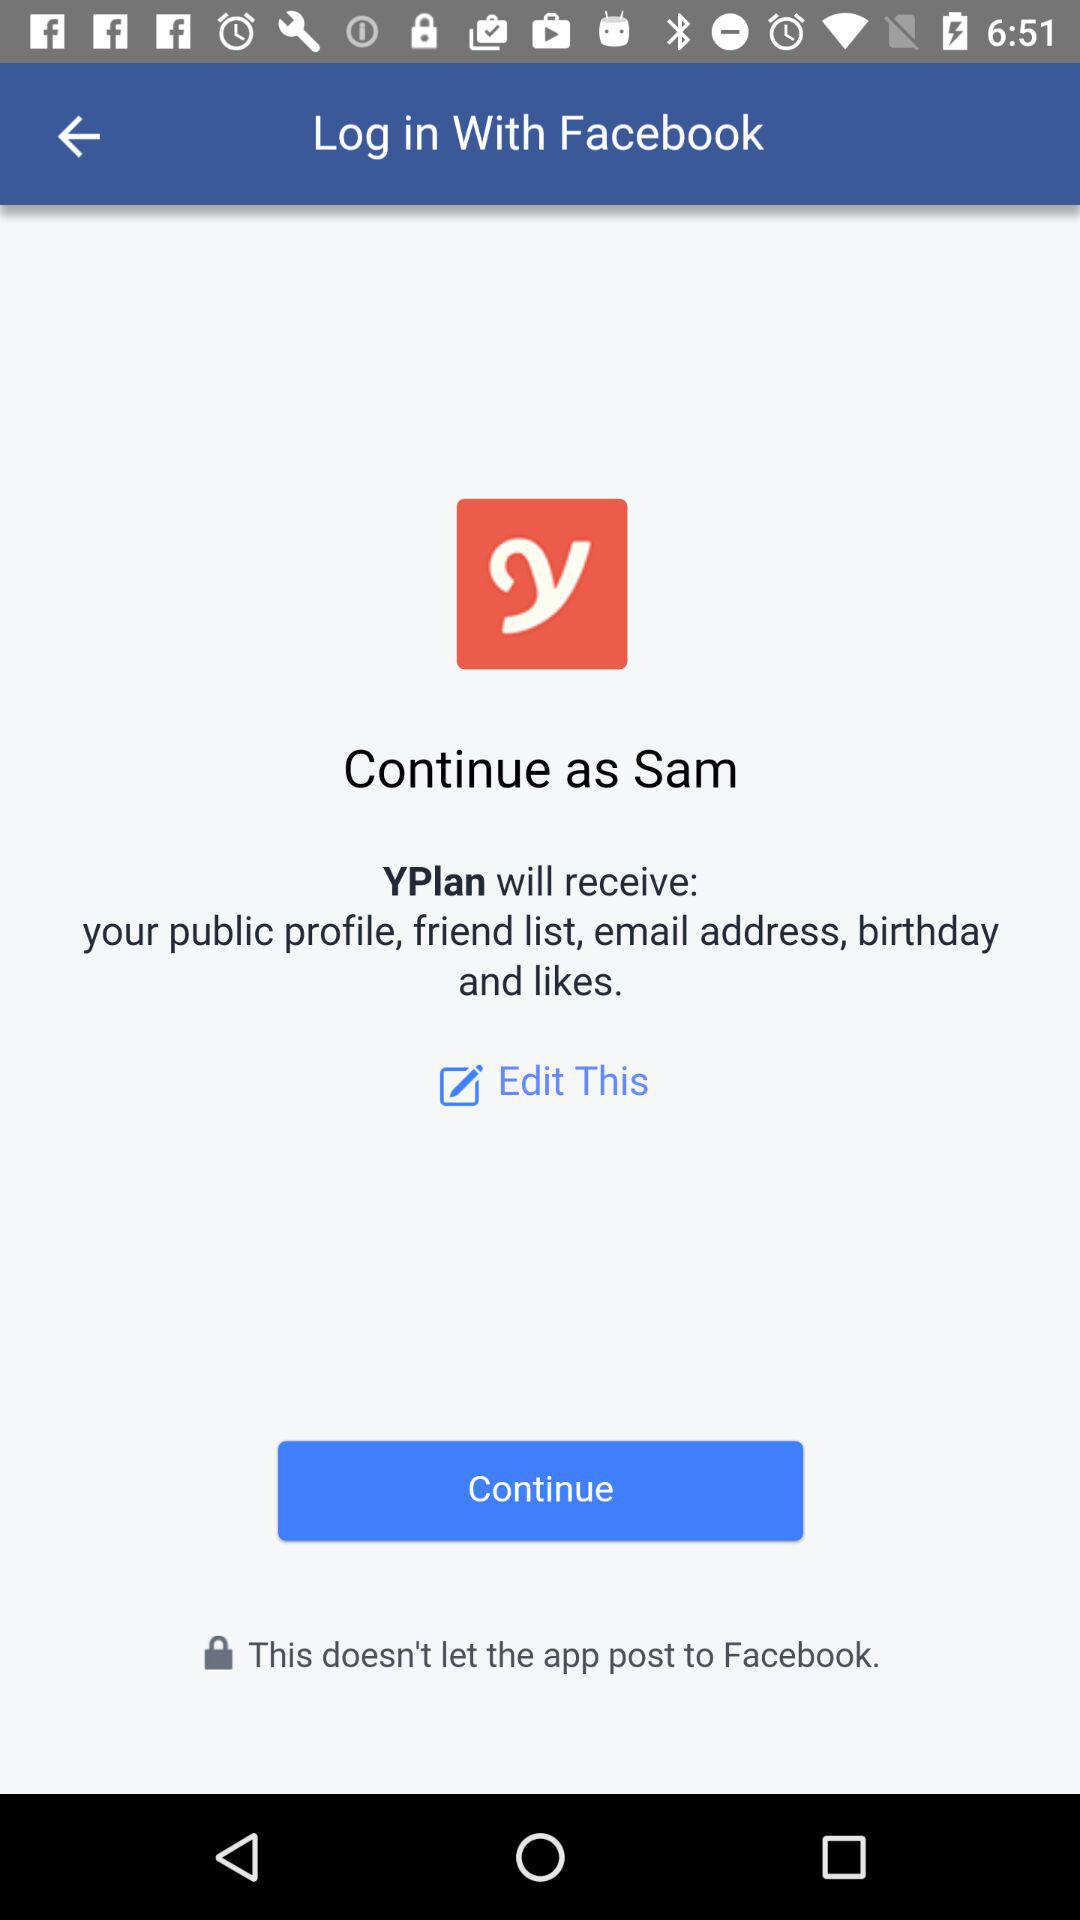What is the name of the user? The user name is Sam. 